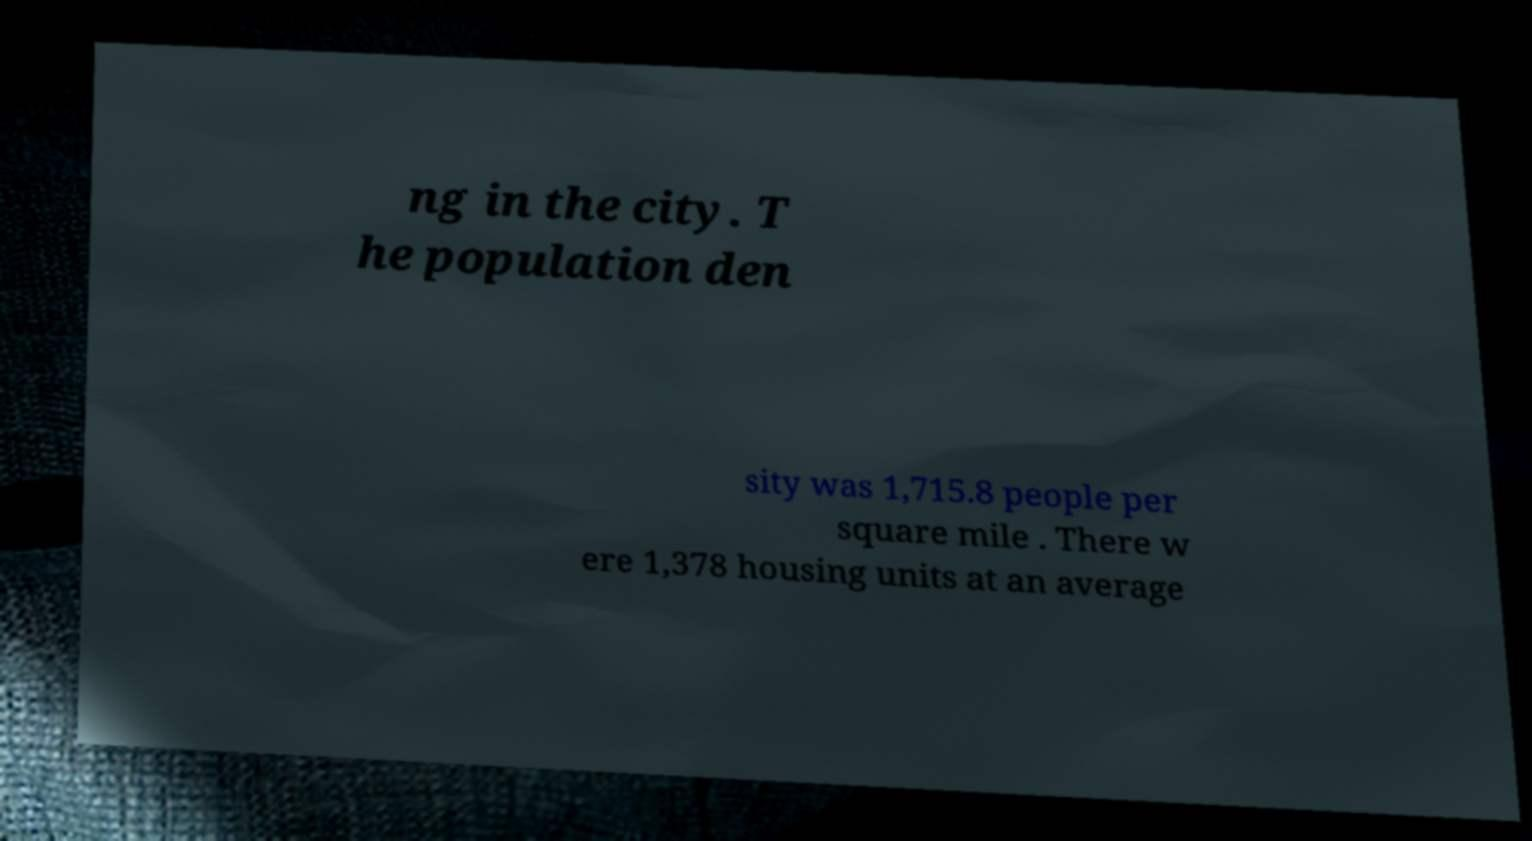Please identify and transcribe the text found in this image. ng in the city. T he population den sity was 1,715.8 people per square mile . There w ere 1,378 housing units at an average 